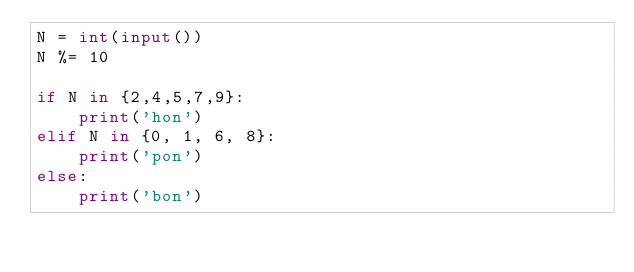Convert code to text. <code><loc_0><loc_0><loc_500><loc_500><_Python_>N = int(input())
N %= 10

if N in {2,4,5,7,9}:
    print('hon')
elif N in {0, 1, 6, 8}:
    print('pon')
else:
    print('bon')</code> 